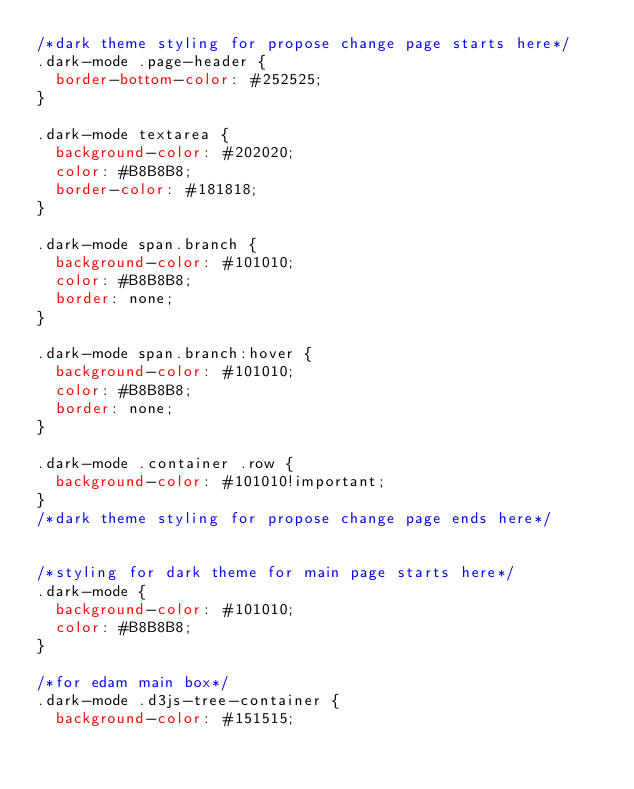<code> <loc_0><loc_0><loc_500><loc_500><_CSS_>/*dark theme styling for propose change page starts here*/
.dark-mode .page-header {
  border-bottom-color: #252525;
}

.dark-mode textarea {
  background-color: #202020;
  color: #B8B8B8;
  border-color: #181818;
}

.dark-mode span.branch {
  background-color: #101010;
  color: #B8B8B8;
  border: none;
}

.dark-mode span.branch:hover {
  background-color: #101010;
  color: #B8B8B8;
  border: none;
}

.dark-mode .container .row {
  background-color: #101010!important;
}
/*dark theme styling for propose change page ends here*/


/*styling for dark theme for main page starts here*/
.dark-mode {
  background-color: #101010;
  color: #B8B8B8;
}

/*for edam main box*/
.dark-mode .d3js-tree-container {
  background-color: #151515;</code> 